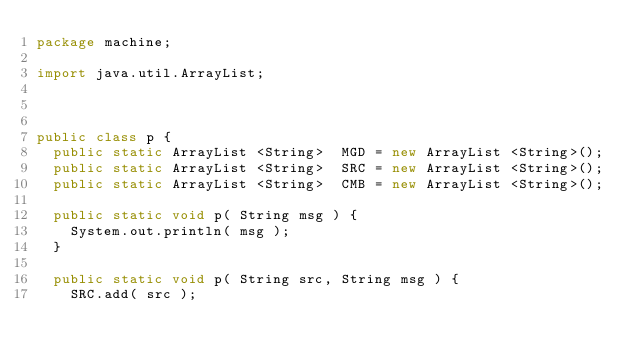<code> <loc_0><loc_0><loc_500><loc_500><_Java_>package machine;

import java.util.ArrayList;



public class p {
	public static ArrayList <String>	MGD	= new ArrayList <String>();
	public static ArrayList <String>	SRC	= new ArrayList <String>();
	public static ArrayList <String>	CMB	= new ArrayList <String>();

	public static void p( String msg ) {
		System.out.println( msg );
	}

	public static void p( String src, String msg ) {
		SRC.add( src );</code> 